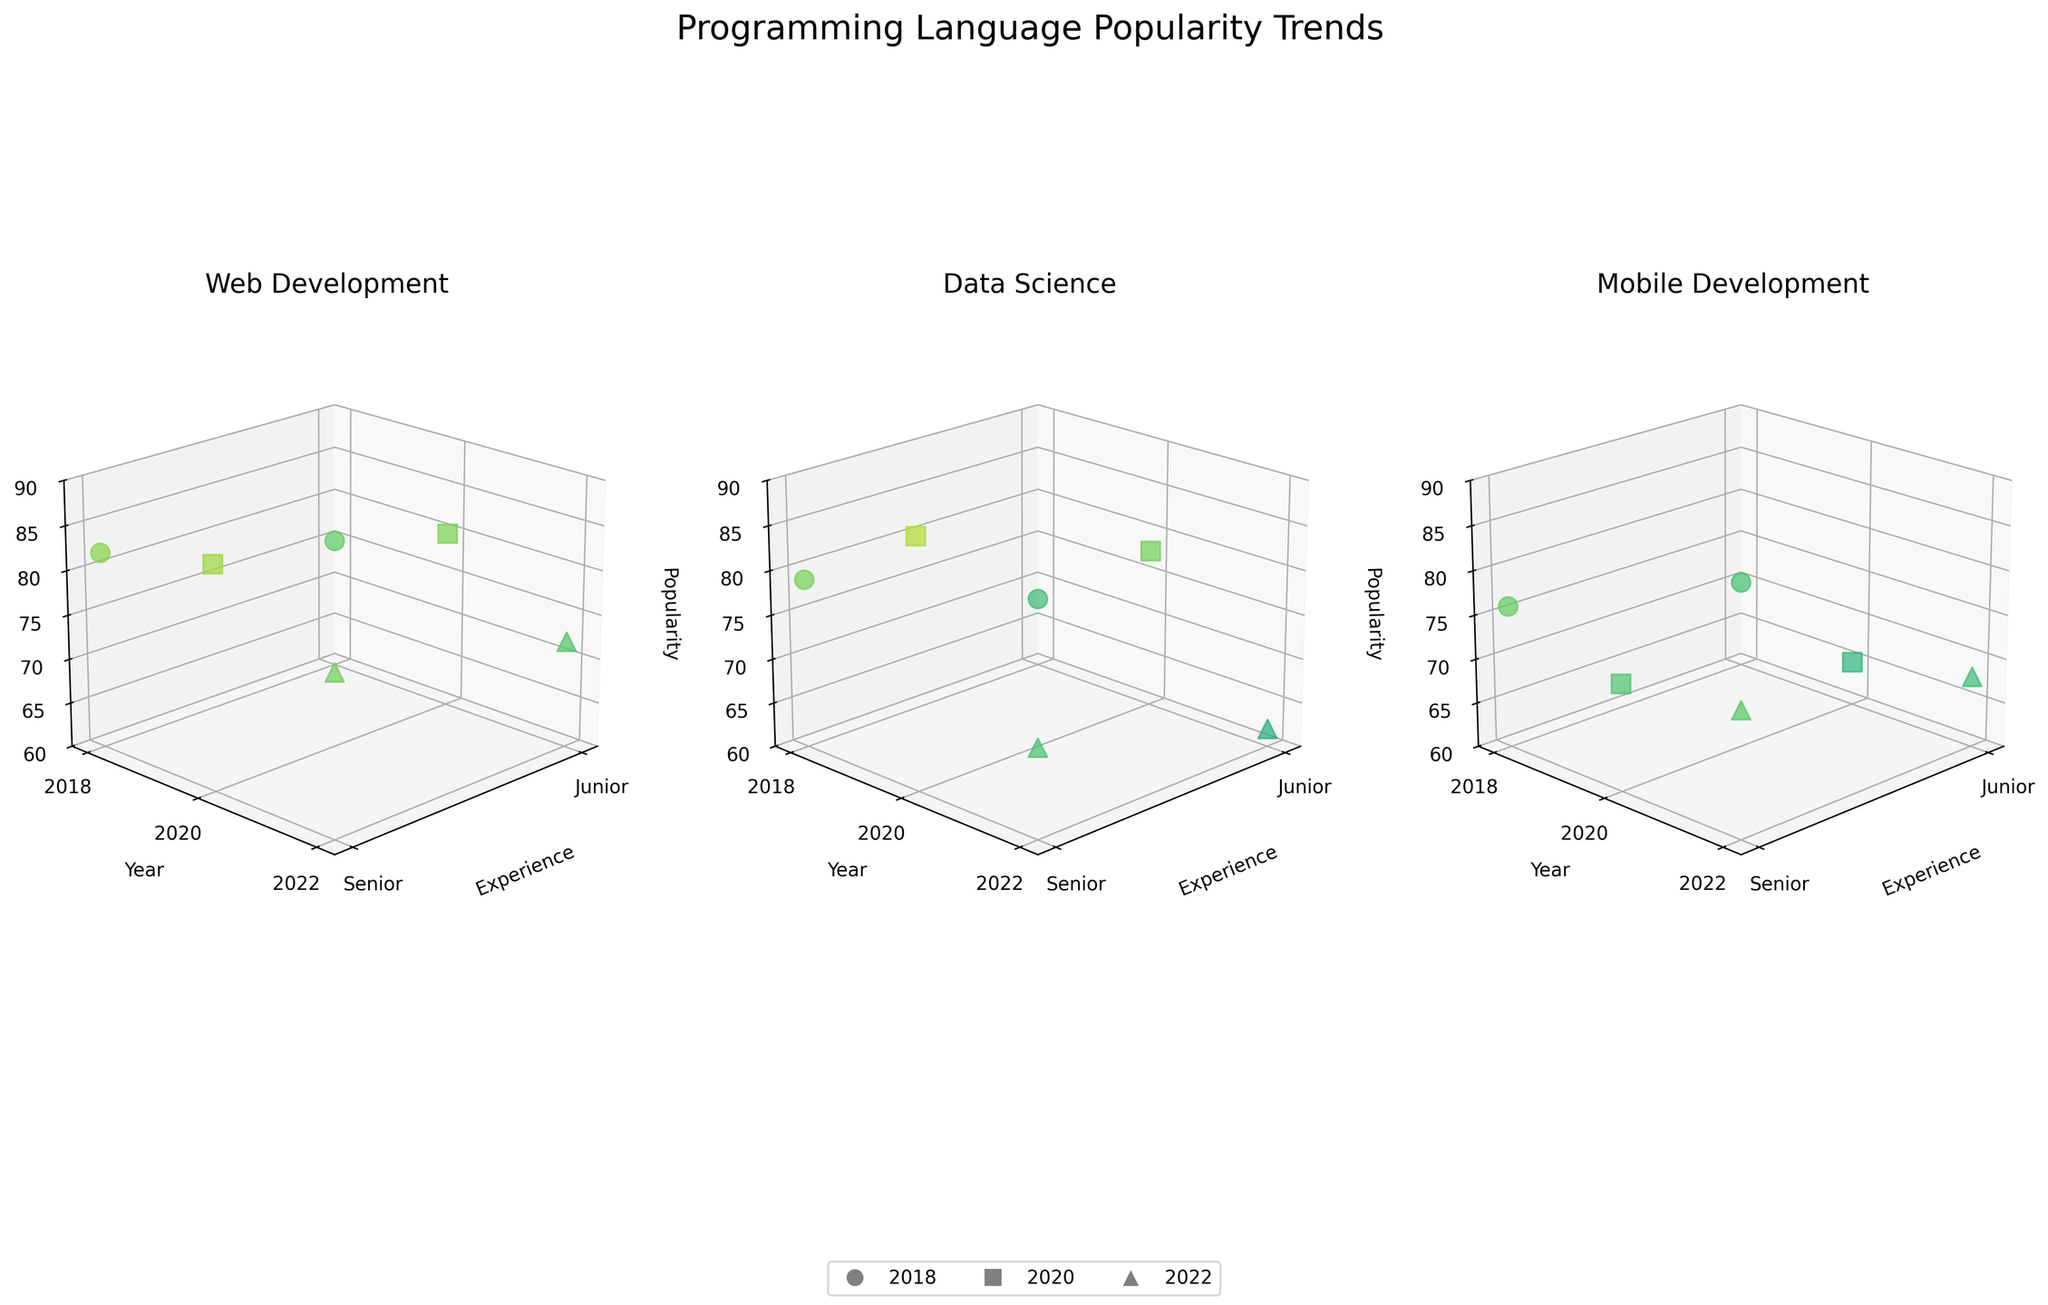How many industries are represented in the figure? The figure has three subplots, each representing a different industry. Thus, by counting the subplots, we identify three industries.
Answer: 3 What year shows the highest popularity for Data Science with Junior experience level? By examining the data points in the subplot for Data Science, the highest z-value (indicating popularity) for Junior experience occurs in 2020.
Answer: 2020 Which programming language is represented in the Web Development subplot for the year 2022? By analyzing the data points in the Web Development subplot for the year 2022, the name of the language shown is TypeScript.
Answer: TypeScript Compare the popularity of the programming languages in Mobile Development between Junior and Senior levels in 2022. Which level is more popular? In the Mobile Development subplot for 2022, compare the z-values of Junior and Senior levels. Junior's popularity is 68, while Senior's is 74. Therefore, Senior is more popular.
Answer: Senior What is the overall trend in popularity for JavaScript in Web Development from 2018 to 2020? By examining the Web Development subplot and looking at the data points for JavaScript in the years 2018 and 2020, the popularity increased from 75 (Junior) and 82 (Senior) in 2018 to 80 (Junior) and 85 (Senior) in 2020.
Answer: Increasing Identify which industry shows a new programming language introduced in 2022, which was not present in the previous years. By examining the subplots, it shows that Mobile Development introduced Swift in 2022, a language not present in 2018 or 2020.
Answer: Mobile Development Which experience level in Data Science shows a higher popularity in 2020? Referring to the Data Science subplot for the year 2020, the z-values are compared between Junior (78) and Senior (88). Senior shows a higher popularity.
Answer: Senior Calculate the average popularity of programming languages for the Junior experience level across all industries in 2020. The data points for Junior in all industries in 2020 are: Web Development (80), Data Science (78), and Mobile Development (65). Average is (80 + 78 + 65) / 3 = 74.3.
Answer: 74.3 Did the popularity of Python for Junior experience in Data Science increase or decrease from 2018 to 2020? By comparing the z-values for Python in Data Science for Junior experience in 2018 (68) and 2020 (78), we see an increase.
Answer: Increase 